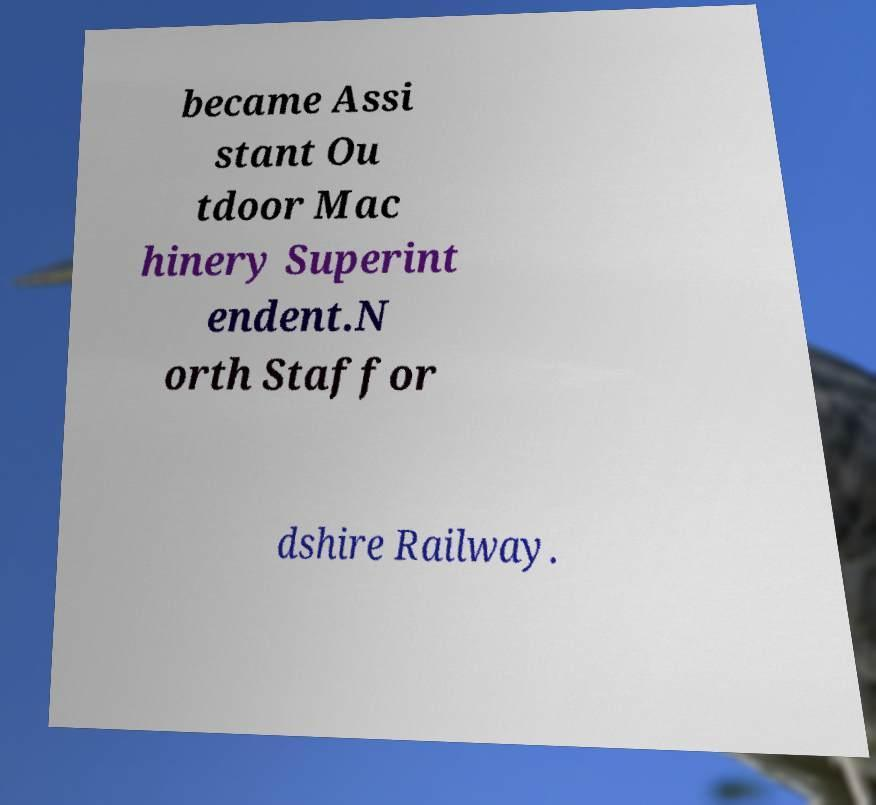Please identify and transcribe the text found in this image. became Assi stant Ou tdoor Mac hinery Superint endent.N orth Staffor dshire Railway. 